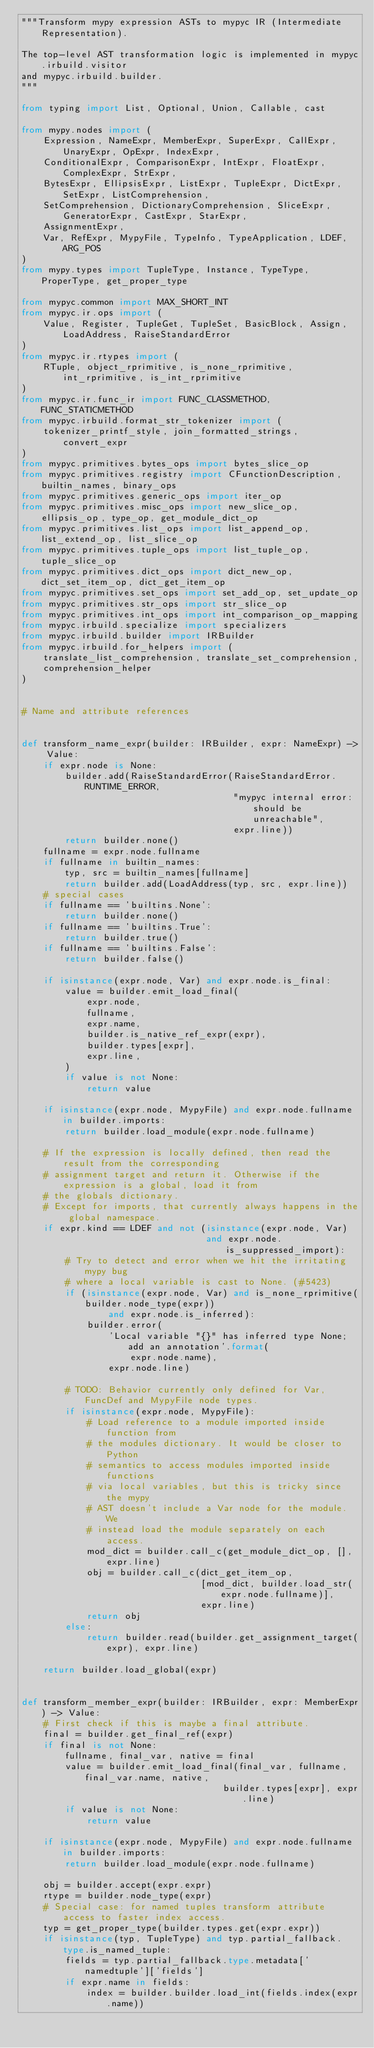<code> <loc_0><loc_0><loc_500><loc_500><_Python_>"""Transform mypy expression ASTs to mypyc IR (Intermediate Representation).

The top-level AST transformation logic is implemented in mypyc.irbuild.visitor
and mypyc.irbuild.builder.
"""

from typing import List, Optional, Union, Callable, cast

from mypy.nodes import (
    Expression, NameExpr, MemberExpr, SuperExpr, CallExpr, UnaryExpr, OpExpr, IndexExpr,
    ConditionalExpr, ComparisonExpr, IntExpr, FloatExpr, ComplexExpr, StrExpr,
    BytesExpr, EllipsisExpr, ListExpr, TupleExpr, DictExpr, SetExpr, ListComprehension,
    SetComprehension, DictionaryComprehension, SliceExpr, GeneratorExpr, CastExpr, StarExpr,
    AssignmentExpr,
    Var, RefExpr, MypyFile, TypeInfo, TypeApplication, LDEF, ARG_POS
)
from mypy.types import TupleType, Instance, TypeType, ProperType, get_proper_type

from mypyc.common import MAX_SHORT_INT
from mypyc.ir.ops import (
    Value, Register, TupleGet, TupleSet, BasicBlock, Assign, LoadAddress, RaiseStandardError
)
from mypyc.ir.rtypes import (
    RTuple, object_rprimitive, is_none_rprimitive, int_rprimitive, is_int_rprimitive
)
from mypyc.ir.func_ir import FUNC_CLASSMETHOD, FUNC_STATICMETHOD
from mypyc.irbuild.format_str_tokenizer import (
    tokenizer_printf_style, join_formatted_strings, convert_expr
)
from mypyc.primitives.bytes_ops import bytes_slice_op
from mypyc.primitives.registry import CFunctionDescription, builtin_names, binary_ops
from mypyc.primitives.generic_ops import iter_op
from mypyc.primitives.misc_ops import new_slice_op, ellipsis_op, type_op, get_module_dict_op
from mypyc.primitives.list_ops import list_append_op, list_extend_op, list_slice_op
from mypyc.primitives.tuple_ops import list_tuple_op, tuple_slice_op
from mypyc.primitives.dict_ops import dict_new_op, dict_set_item_op, dict_get_item_op
from mypyc.primitives.set_ops import set_add_op, set_update_op
from mypyc.primitives.str_ops import str_slice_op
from mypyc.primitives.int_ops import int_comparison_op_mapping
from mypyc.irbuild.specialize import specializers
from mypyc.irbuild.builder import IRBuilder
from mypyc.irbuild.for_helpers import (
    translate_list_comprehension, translate_set_comprehension,
    comprehension_helper
)


# Name and attribute references


def transform_name_expr(builder: IRBuilder, expr: NameExpr) -> Value:
    if expr.node is None:
        builder.add(RaiseStandardError(RaiseStandardError.RUNTIME_ERROR,
                                       "mypyc internal error: should be unreachable",
                                       expr.line))
        return builder.none()
    fullname = expr.node.fullname
    if fullname in builtin_names:
        typ, src = builtin_names[fullname]
        return builder.add(LoadAddress(typ, src, expr.line))
    # special cases
    if fullname == 'builtins.None':
        return builder.none()
    if fullname == 'builtins.True':
        return builder.true()
    if fullname == 'builtins.False':
        return builder.false()

    if isinstance(expr.node, Var) and expr.node.is_final:
        value = builder.emit_load_final(
            expr.node,
            fullname,
            expr.name,
            builder.is_native_ref_expr(expr),
            builder.types[expr],
            expr.line,
        )
        if value is not None:
            return value

    if isinstance(expr.node, MypyFile) and expr.node.fullname in builder.imports:
        return builder.load_module(expr.node.fullname)

    # If the expression is locally defined, then read the result from the corresponding
    # assignment target and return it. Otherwise if the expression is a global, load it from
    # the globals dictionary.
    # Except for imports, that currently always happens in the global namespace.
    if expr.kind == LDEF and not (isinstance(expr.node, Var)
                                  and expr.node.is_suppressed_import):
        # Try to detect and error when we hit the irritating mypy bug
        # where a local variable is cast to None. (#5423)
        if (isinstance(expr.node, Var) and is_none_rprimitive(builder.node_type(expr))
                and expr.node.is_inferred):
            builder.error(
                'Local variable "{}" has inferred type None; add an annotation'.format(
                    expr.node.name),
                expr.node.line)

        # TODO: Behavior currently only defined for Var, FuncDef and MypyFile node types.
        if isinstance(expr.node, MypyFile):
            # Load reference to a module imported inside function from
            # the modules dictionary. It would be closer to Python
            # semantics to access modules imported inside functions
            # via local variables, but this is tricky since the mypy
            # AST doesn't include a Var node for the module. We
            # instead load the module separately on each access.
            mod_dict = builder.call_c(get_module_dict_op, [], expr.line)
            obj = builder.call_c(dict_get_item_op,
                                 [mod_dict, builder.load_str(expr.node.fullname)],
                                 expr.line)
            return obj
        else:
            return builder.read(builder.get_assignment_target(expr), expr.line)

    return builder.load_global(expr)


def transform_member_expr(builder: IRBuilder, expr: MemberExpr) -> Value:
    # First check if this is maybe a final attribute.
    final = builder.get_final_ref(expr)
    if final is not None:
        fullname, final_var, native = final
        value = builder.emit_load_final(final_var, fullname, final_var.name, native,
                                     builder.types[expr], expr.line)
        if value is not None:
            return value

    if isinstance(expr.node, MypyFile) and expr.node.fullname in builder.imports:
        return builder.load_module(expr.node.fullname)

    obj = builder.accept(expr.expr)
    rtype = builder.node_type(expr)
    # Special case: for named tuples transform attribute access to faster index access.
    typ = get_proper_type(builder.types.get(expr.expr))
    if isinstance(typ, TupleType) and typ.partial_fallback.type.is_named_tuple:
        fields = typ.partial_fallback.type.metadata['namedtuple']['fields']
        if expr.name in fields:
            index = builder.builder.load_int(fields.index(expr.name))</code> 